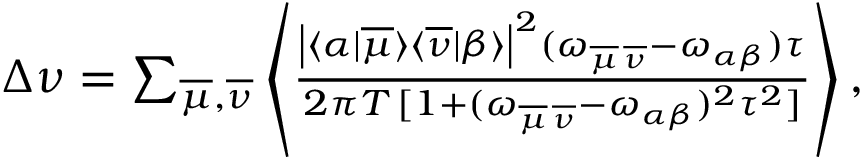<formula> <loc_0><loc_0><loc_500><loc_500>\begin{array} { r } { \Delta \nu = \sum _ { \overline { \mu } , \overline { \nu } } \left \langle \frac { \left | \langle \alpha | \overline { \mu } \rangle \langle \overline { \nu } | \beta \rangle \right | ^ { 2 } ( \omega _ { \overline { \mu } \, \overline { \nu } } - \omega _ { \alpha \beta } ) \tau } { 2 \pi T \, [ 1 + ( \omega _ { \overline { \mu } \, \overline { \nu } } - \omega _ { \alpha \beta } ) ^ { 2 } \tau ^ { 2 } ] } \right \rangle , } \end{array}</formula> 